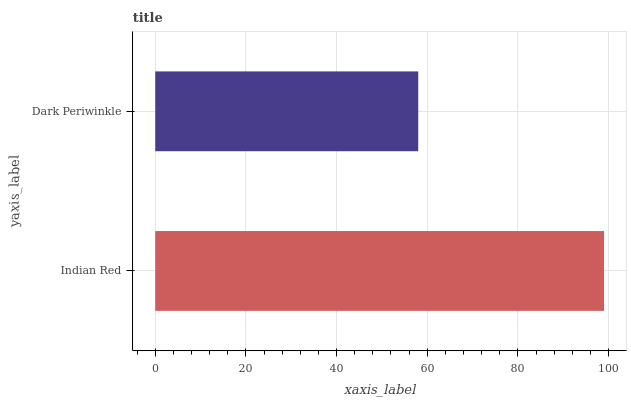Is Dark Periwinkle the minimum?
Answer yes or no. Yes. Is Indian Red the maximum?
Answer yes or no. Yes. Is Dark Periwinkle the maximum?
Answer yes or no. No. Is Indian Red greater than Dark Periwinkle?
Answer yes or no. Yes. Is Dark Periwinkle less than Indian Red?
Answer yes or no. Yes. Is Dark Periwinkle greater than Indian Red?
Answer yes or no. No. Is Indian Red less than Dark Periwinkle?
Answer yes or no. No. Is Indian Red the high median?
Answer yes or no. Yes. Is Dark Periwinkle the low median?
Answer yes or no. Yes. Is Dark Periwinkle the high median?
Answer yes or no. No. Is Indian Red the low median?
Answer yes or no. No. 